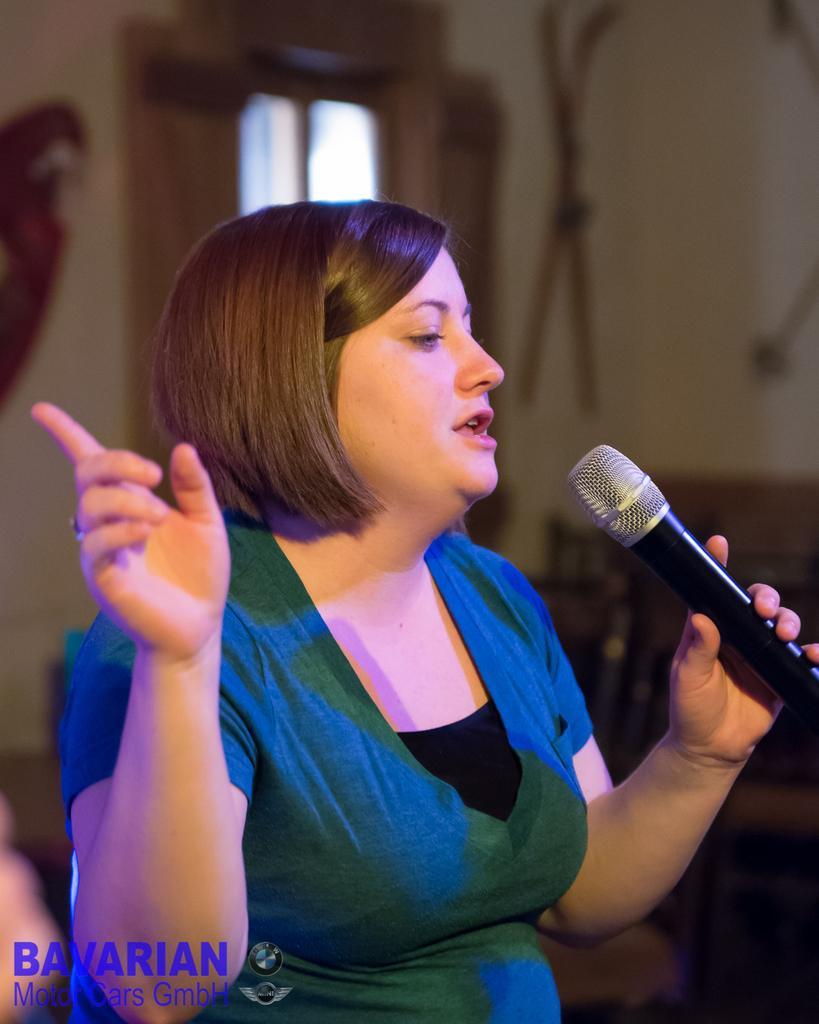Could you give a brief overview of what you see in this image? In the picture there is a woman,she is holding a mic and she is wearing blue dress and the background of the woman is blur. 